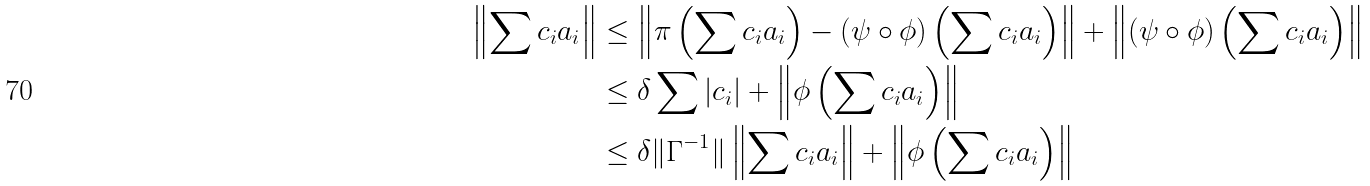Convert formula to latex. <formula><loc_0><loc_0><loc_500><loc_500>\left \| \sum c _ { i } a _ { i } \right \| & \leq \left \| \pi \left ( \sum c _ { i } a _ { i } \right ) - ( \psi \circ \phi ) \left ( \sum c _ { i } a _ { i } \right ) \right \| + \left \| ( \psi \circ \phi ) \left ( \sum c _ { i } a _ { i } \right ) \right \| \\ & \leq \delta \sum | c _ { i } | + \left \| \phi \left ( \sum c _ { i } a _ { i } \right ) \right \| \\ & \leq \delta \| \Gamma ^ { - 1 } \| \left \| \sum c _ { i } a _ { i } \right \| + \left \| \phi \left ( \sum c _ { i } a _ { i } \right ) \right \|</formula> 